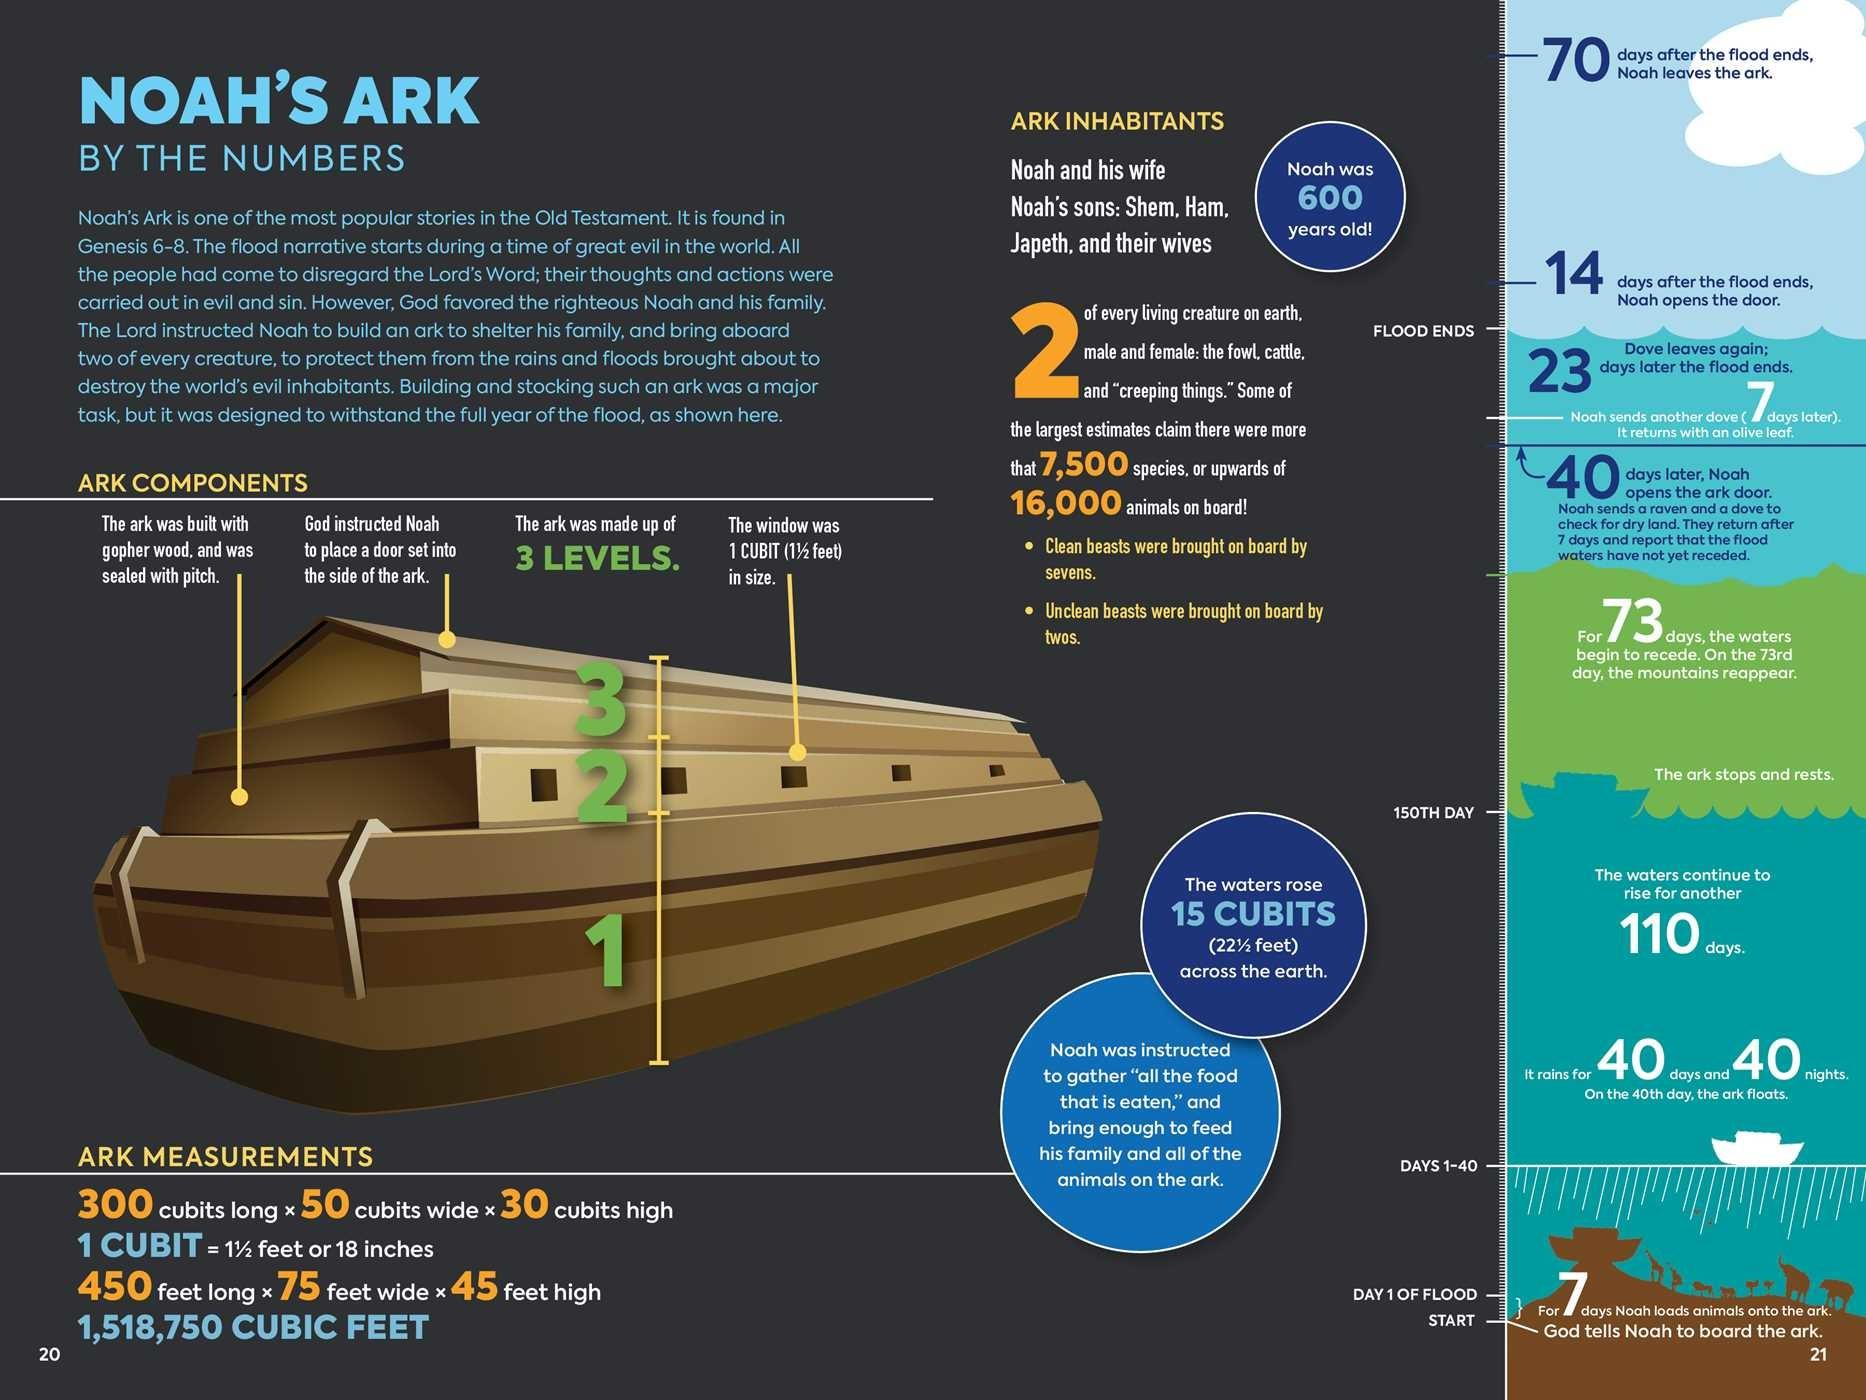Highlight a few significant elements in this photo. The material used to construct the ark is gopher wood. 